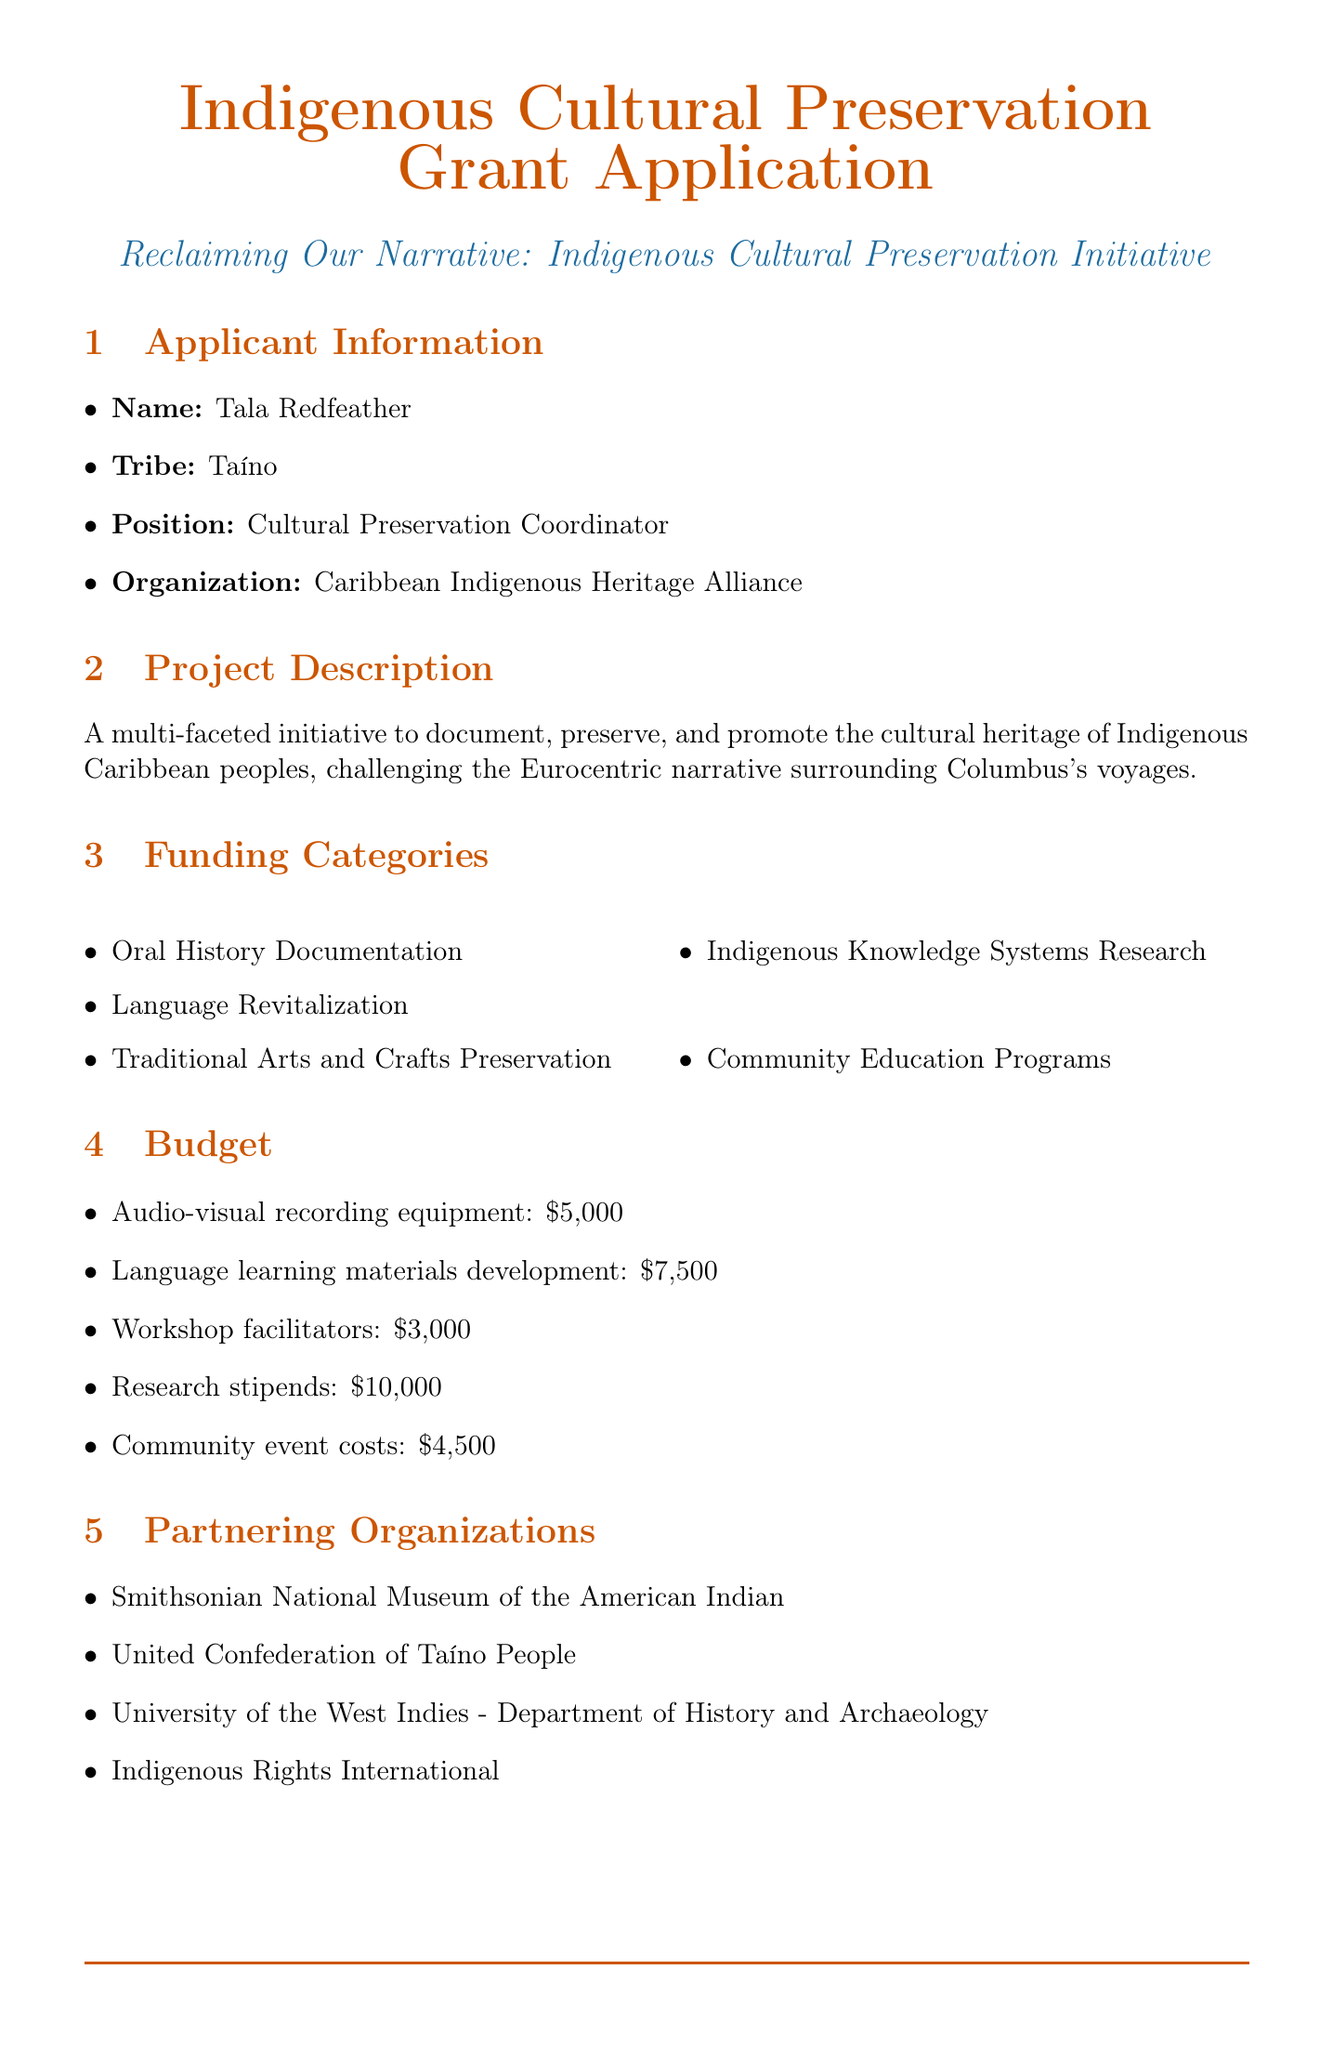What is the project title? The project title is stated clearly at the beginning of the document.
Answer: Reclaiming Our Narrative: Indigenous Cultural Preservation Initiative Who is the Cultural Preservation Coordinator? The name and position of the applicant are included in the applicant information section.
Answer: Tala Redfeather What are the total costs for audio-visual recording equipment? The budget item includes a specific cost for audio-visual recording equipment.
Answer: 5000 What is one expected outcome of the project? The document outlines expected outcomes that indicate the project's goals.
Answer: Increased awareness of Indigenous Caribbean history and culture When is the project scheduled to start? The project timeline includes a start date for the initiative.
Answer: January 15, 2024 How many partner organizations are listed? The partnering organizations section details the collaborative entities involved.
Answer: 4 What type of evaluation method involves community feedback? The document specifies several evaluation methods, including those related to community involvement.
Answer: Community feedback surveys What amount is requested from the Ford Foundation? The additional funding sources section lists proposed amounts and their status.
Answer: 40000 What is the purpose of workshop facilitators in the budget? The budget item details the purpose of hiring workshop facilitators for the project.
Answer: To lead traditional craft workshops and knowledge sharing sessions 